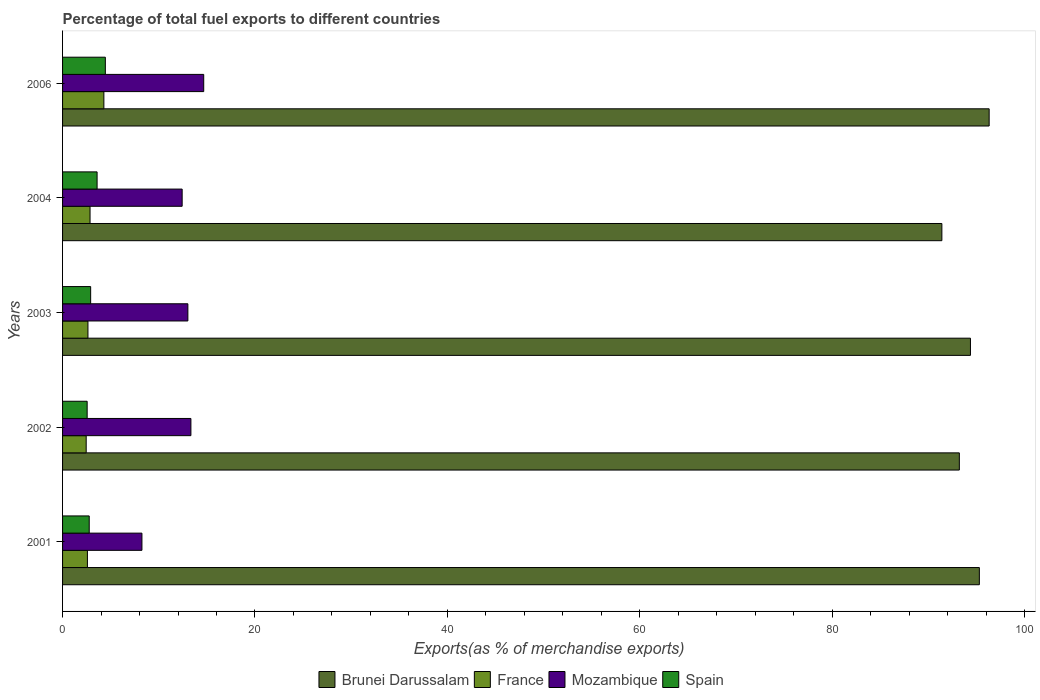How many different coloured bars are there?
Provide a succinct answer. 4. Are the number of bars per tick equal to the number of legend labels?
Give a very brief answer. Yes. Are the number of bars on each tick of the Y-axis equal?
Your answer should be compact. Yes. How many bars are there on the 4th tick from the top?
Your answer should be compact. 4. What is the label of the 1st group of bars from the top?
Offer a terse response. 2006. In how many cases, is the number of bars for a given year not equal to the number of legend labels?
Make the answer very short. 0. What is the percentage of exports to different countries in France in 2006?
Keep it short and to the point. 4.29. Across all years, what is the maximum percentage of exports to different countries in Brunei Darussalam?
Offer a terse response. 96.33. Across all years, what is the minimum percentage of exports to different countries in Brunei Darussalam?
Offer a terse response. 91.41. In which year was the percentage of exports to different countries in Spain maximum?
Your answer should be very brief. 2006. What is the total percentage of exports to different countries in Mozambique in the graph?
Make the answer very short. 61.73. What is the difference between the percentage of exports to different countries in Spain in 2002 and that in 2006?
Your answer should be compact. -1.89. What is the difference between the percentage of exports to different countries in France in 2004 and the percentage of exports to different countries in Mozambique in 2002?
Make the answer very short. -10.49. What is the average percentage of exports to different countries in France per year?
Provide a succinct answer. 2.97. In the year 2006, what is the difference between the percentage of exports to different countries in France and percentage of exports to different countries in Mozambique?
Your answer should be compact. -10.38. What is the ratio of the percentage of exports to different countries in Mozambique in 2001 to that in 2003?
Offer a very short reply. 0.63. Is the percentage of exports to different countries in Spain in 2002 less than that in 2004?
Keep it short and to the point. Yes. What is the difference between the highest and the second highest percentage of exports to different countries in Mozambique?
Your answer should be very brief. 1.33. What is the difference between the highest and the lowest percentage of exports to different countries in Spain?
Give a very brief answer. 1.89. In how many years, is the percentage of exports to different countries in Mozambique greater than the average percentage of exports to different countries in Mozambique taken over all years?
Provide a short and direct response. 4. Is the sum of the percentage of exports to different countries in France in 2001 and 2004 greater than the maximum percentage of exports to different countries in Mozambique across all years?
Your answer should be compact. No. What does the 2nd bar from the top in 2006 represents?
Your response must be concise. Mozambique. What does the 4th bar from the bottom in 2006 represents?
Make the answer very short. Spain. Are all the bars in the graph horizontal?
Make the answer very short. Yes. What is the difference between two consecutive major ticks on the X-axis?
Give a very brief answer. 20. Does the graph contain grids?
Provide a short and direct response. No. What is the title of the graph?
Provide a succinct answer. Percentage of total fuel exports to different countries. What is the label or title of the X-axis?
Your answer should be compact. Exports(as % of merchandise exports). What is the label or title of the Y-axis?
Provide a short and direct response. Years. What is the Exports(as % of merchandise exports) of Brunei Darussalam in 2001?
Keep it short and to the point. 95.31. What is the Exports(as % of merchandise exports) of France in 2001?
Offer a terse response. 2.58. What is the Exports(as % of merchandise exports) of Mozambique in 2001?
Provide a short and direct response. 8.25. What is the Exports(as % of merchandise exports) of Spain in 2001?
Keep it short and to the point. 2.77. What is the Exports(as % of merchandise exports) in Brunei Darussalam in 2002?
Your answer should be compact. 93.23. What is the Exports(as % of merchandise exports) in France in 2002?
Offer a very short reply. 2.46. What is the Exports(as % of merchandise exports) in Mozambique in 2002?
Your response must be concise. 13.34. What is the Exports(as % of merchandise exports) of Spain in 2002?
Offer a terse response. 2.56. What is the Exports(as % of merchandise exports) in Brunei Darussalam in 2003?
Offer a very short reply. 94.38. What is the Exports(as % of merchandise exports) of France in 2003?
Your answer should be compact. 2.64. What is the Exports(as % of merchandise exports) of Mozambique in 2003?
Your response must be concise. 13.03. What is the Exports(as % of merchandise exports) in Spain in 2003?
Give a very brief answer. 2.92. What is the Exports(as % of merchandise exports) of Brunei Darussalam in 2004?
Your answer should be compact. 91.41. What is the Exports(as % of merchandise exports) of France in 2004?
Keep it short and to the point. 2.86. What is the Exports(as % of merchandise exports) of Mozambique in 2004?
Your answer should be compact. 12.43. What is the Exports(as % of merchandise exports) of Spain in 2004?
Give a very brief answer. 3.59. What is the Exports(as % of merchandise exports) in Brunei Darussalam in 2006?
Offer a very short reply. 96.33. What is the Exports(as % of merchandise exports) in France in 2006?
Offer a terse response. 4.29. What is the Exports(as % of merchandise exports) of Mozambique in 2006?
Offer a terse response. 14.67. What is the Exports(as % of merchandise exports) of Spain in 2006?
Your answer should be very brief. 4.45. Across all years, what is the maximum Exports(as % of merchandise exports) of Brunei Darussalam?
Keep it short and to the point. 96.33. Across all years, what is the maximum Exports(as % of merchandise exports) in France?
Your answer should be compact. 4.29. Across all years, what is the maximum Exports(as % of merchandise exports) in Mozambique?
Ensure brevity in your answer.  14.67. Across all years, what is the maximum Exports(as % of merchandise exports) in Spain?
Your answer should be very brief. 4.45. Across all years, what is the minimum Exports(as % of merchandise exports) in Brunei Darussalam?
Offer a very short reply. 91.41. Across all years, what is the minimum Exports(as % of merchandise exports) in France?
Give a very brief answer. 2.46. Across all years, what is the minimum Exports(as % of merchandise exports) of Mozambique?
Offer a very short reply. 8.25. Across all years, what is the minimum Exports(as % of merchandise exports) in Spain?
Keep it short and to the point. 2.56. What is the total Exports(as % of merchandise exports) in Brunei Darussalam in the graph?
Keep it short and to the point. 470.65. What is the total Exports(as % of merchandise exports) in France in the graph?
Your response must be concise. 14.83. What is the total Exports(as % of merchandise exports) in Mozambique in the graph?
Ensure brevity in your answer.  61.73. What is the total Exports(as % of merchandise exports) of Spain in the graph?
Ensure brevity in your answer.  16.28. What is the difference between the Exports(as % of merchandise exports) of Brunei Darussalam in 2001 and that in 2002?
Give a very brief answer. 2.08. What is the difference between the Exports(as % of merchandise exports) in France in 2001 and that in 2002?
Provide a succinct answer. 0.13. What is the difference between the Exports(as % of merchandise exports) in Mozambique in 2001 and that in 2002?
Give a very brief answer. -5.09. What is the difference between the Exports(as % of merchandise exports) in Spain in 2001 and that in 2002?
Ensure brevity in your answer.  0.22. What is the difference between the Exports(as % of merchandise exports) in Brunei Darussalam in 2001 and that in 2003?
Provide a succinct answer. 0.92. What is the difference between the Exports(as % of merchandise exports) of France in 2001 and that in 2003?
Ensure brevity in your answer.  -0.05. What is the difference between the Exports(as % of merchandise exports) in Mozambique in 2001 and that in 2003?
Ensure brevity in your answer.  -4.78. What is the difference between the Exports(as % of merchandise exports) of Spain in 2001 and that in 2003?
Offer a terse response. -0.15. What is the difference between the Exports(as % of merchandise exports) of Brunei Darussalam in 2001 and that in 2004?
Give a very brief answer. 3.9. What is the difference between the Exports(as % of merchandise exports) of France in 2001 and that in 2004?
Provide a short and direct response. -0.27. What is the difference between the Exports(as % of merchandise exports) of Mozambique in 2001 and that in 2004?
Your answer should be very brief. -4.18. What is the difference between the Exports(as % of merchandise exports) of Spain in 2001 and that in 2004?
Your response must be concise. -0.82. What is the difference between the Exports(as % of merchandise exports) of Brunei Darussalam in 2001 and that in 2006?
Give a very brief answer. -1.02. What is the difference between the Exports(as % of merchandise exports) of France in 2001 and that in 2006?
Your response must be concise. -1.71. What is the difference between the Exports(as % of merchandise exports) in Mozambique in 2001 and that in 2006?
Provide a short and direct response. -6.42. What is the difference between the Exports(as % of merchandise exports) of Spain in 2001 and that in 2006?
Provide a short and direct response. -1.68. What is the difference between the Exports(as % of merchandise exports) in Brunei Darussalam in 2002 and that in 2003?
Provide a succinct answer. -1.16. What is the difference between the Exports(as % of merchandise exports) in France in 2002 and that in 2003?
Offer a terse response. -0.18. What is the difference between the Exports(as % of merchandise exports) of Mozambique in 2002 and that in 2003?
Provide a succinct answer. 0.32. What is the difference between the Exports(as % of merchandise exports) of Spain in 2002 and that in 2003?
Make the answer very short. -0.36. What is the difference between the Exports(as % of merchandise exports) of Brunei Darussalam in 2002 and that in 2004?
Your answer should be very brief. 1.82. What is the difference between the Exports(as % of merchandise exports) in France in 2002 and that in 2004?
Your answer should be very brief. -0.4. What is the difference between the Exports(as % of merchandise exports) in Mozambique in 2002 and that in 2004?
Ensure brevity in your answer.  0.91. What is the difference between the Exports(as % of merchandise exports) of Spain in 2002 and that in 2004?
Offer a terse response. -1.03. What is the difference between the Exports(as % of merchandise exports) of Brunei Darussalam in 2002 and that in 2006?
Your answer should be very brief. -3.1. What is the difference between the Exports(as % of merchandise exports) of France in 2002 and that in 2006?
Offer a very short reply. -1.84. What is the difference between the Exports(as % of merchandise exports) in Mozambique in 2002 and that in 2006?
Provide a short and direct response. -1.33. What is the difference between the Exports(as % of merchandise exports) of Spain in 2002 and that in 2006?
Offer a terse response. -1.89. What is the difference between the Exports(as % of merchandise exports) in Brunei Darussalam in 2003 and that in 2004?
Your answer should be very brief. 2.97. What is the difference between the Exports(as % of merchandise exports) in France in 2003 and that in 2004?
Keep it short and to the point. -0.22. What is the difference between the Exports(as % of merchandise exports) of Mozambique in 2003 and that in 2004?
Ensure brevity in your answer.  0.59. What is the difference between the Exports(as % of merchandise exports) of Spain in 2003 and that in 2004?
Provide a succinct answer. -0.67. What is the difference between the Exports(as % of merchandise exports) in Brunei Darussalam in 2003 and that in 2006?
Your response must be concise. -1.94. What is the difference between the Exports(as % of merchandise exports) of France in 2003 and that in 2006?
Provide a short and direct response. -1.66. What is the difference between the Exports(as % of merchandise exports) in Mozambique in 2003 and that in 2006?
Offer a very short reply. -1.65. What is the difference between the Exports(as % of merchandise exports) of Spain in 2003 and that in 2006?
Give a very brief answer. -1.53. What is the difference between the Exports(as % of merchandise exports) of Brunei Darussalam in 2004 and that in 2006?
Provide a short and direct response. -4.92. What is the difference between the Exports(as % of merchandise exports) of France in 2004 and that in 2006?
Your answer should be compact. -1.44. What is the difference between the Exports(as % of merchandise exports) in Mozambique in 2004 and that in 2006?
Provide a succinct answer. -2.24. What is the difference between the Exports(as % of merchandise exports) of Spain in 2004 and that in 2006?
Offer a very short reply. -0.86. What is the difference between the Exports(as % of merchandise exports) of Brunei Darussalam in 2001 and the Exports(as % of merchandise exports) of France in 2002?
Offer a terse response. 92.85. What is the difference between the Exports(as % of merchandise exports) in Brunei Darussalam in 2001 and the Exports(as % of merchandise exports) in Mozambique in 2002?
Offer a very short reply. 81.96. What is the difference between the Exports(as % of merchandise exports) in Brunei Darussalam in 2001 and the Exports(as % of merchandise exports) in Spain in 2002?
Offer a very short reply. 92.75. What is the difference between the Exports(as % of merchandise exports) of France in 2001 and the Exports(as % of merchandise exports) of Mozambique in 2002?
Provide a succinct answer. -10.76. What is the difference between the Exports(as % of merchandise exports) of France in 2001 and the Exports(as % of merchandise exports) of Spain in 2002?
Offer a very short reply. 0.03. What is the difference between the Exports(as % of merchandise exports) in Mozambique in 2001 and the Exports(as % of merchandise exports) in Spain in 2002?
Offer a very short reply. 5.69. What is the difference between the Exports(as % of merchandise exports) in Brunei Darussalam in 2001 and the Exports(as % of merchandise exports) in France in 2003?
Your answer should be very brief. 92.67. What is the difference between the Exports(as % of merchandise exports) of Brunei Darussalam in 2001 and the Exports(as % of merchandise exports) of Mozambique in 2003?
Your answer should be compact. 82.28. What is the difference between the Exports(as % of merchandise exports) of Brunei Darussalam in 2001 and the Exports(as % of merchandise exports) of Spain in 2003?
Provide a succinct answer. 92.39. What is the difference between the Exports(as % of merchandise exports) of France in 2001 and the Exports(as % of merchandise exports) of Mozambique in 2003?
Offer a very short reply. -10.44. What is the difference between the Exports(as % of merchandise exports) in France in 2001 and the Exports(as % of merchandise exports) in Spain in 2003?
Offer a terse response. -0.34. What is the difference between the Exports(as % of merchandise exports) of Mozambique in 2001 and the Exports(as % of merchandise exports) of Spain in 2003?
Offer a very short reply. 5.33. What is the difference between the Exports(as % of merchandise exports) of Brunei Darussalam in 2001 and the Exports(as % of merchandise exports) of France in 2004?
Keep it short and to the point. 92.45. What is the difference between the Exports(as % of merchandise exports) in Brunei Darussalam in 2001 and the Exports(as % of merchandise exports) in Mozambique in 2004?
Give a very brief answer. 82.87. What is the difference between the Exports(as % of merchandise exports) in Brunei Darussalam in 2001 and the Exports(as % of merchandise exports) in Spain in 2004?
Provide a succinct answer. 91.72. What is the difference between the Exports(as % of merchandise exports) of France in 2001 and the Exports(as % of merchandise exports) of Mozambique in 2004?
Your response must be concise. -9.85. What is the difference between the Exports(as % of merchandise exports) of France in 2001 and the Exports(as % of merchandise exports) of Spain in 2004?
Make the answer very short. -1.01. What is the difference between the Exports(as % of merchandise exports) in Mozambique in 2001 and the Exports(as % of merchandise exports) in Spain in 2004?
Give a very brief answer. 4.66. What is the difference between the Exports(as % of merchandise exports) of Brunei Darussalam in 2001 and the Exports(as % of merchandise exports) of France in 2006?
Your answer should be compact. 91.01. What is the difference between the Exports(as % of merchandise exports) of Brunei Darussalam in 2001 and the Exports(as % of merchandise exports) of Mozambique in 2006?
Your response must be concise. 80.63. What is the difference between the Exports(as % of merchandise exports) in Brunei Darussalam in 2001 and the Exports(as % of merchandise exports) in Spain in 2006?
Your answer should be compact. 90.86. What is the difference between the Exports(as % of merchandise exports) in France in 2001 and the Exports(as % of merchandise exports) in Mozambique in 2006?
Provide a short and direct response. -12.09. What is the difference between the Exports(as % of merchandise exports) in France in 2001 and the Exports(as % of merchandise exports) in Spain in 2006?
Your response must be concise. -1.86. What is the difference between the Exports(as % of merchandise exports) of Mozambique in 2001 and the Exports(as % of merchandise exports) of Spain in 2006?
Make the answer very short. 3.8. What is the difference between the Exports(as % of merchandise exports) in Brunei Darussalam in 2002 and the Exports(as % of merchandise exports) in France in 2003?
Your answer should be very brief. 90.59. What is the difference between the Exports(as % of merchandise exports) of Brunei Darussalam in 2002 and the Exports(as % of merchandise exports) of Mozambique in 2003?
Your answer should be very brief. 80.2. What is the difference between the Exports(as % of merchandise exports) in Brunei Darussalam in 2002 and the Exports(as % of merchandise exports) in Spain in 2003?
Make the answer very short. 90.31. What is the difference between the Exports(as % of merchandise exports) of France in 2002 and the Exports(as % of merchandise exports) of Mozambique in 2003?
Your response must be concise. -10.57. What is the difference between the Exports(as % of merchandise exports) of France in 2002 and the Exports(as % of merchandise exports) of Spain in 2003?
Your answer should be compact. -0.46. What is the difference between the Exports(as % of merchandise exports) in Mozambique in 2002 and the Exports(as % of merchandise exports) in Spain in 2003?
Your answer should be compact. 10.42. What is the difference between the Exports(as % of merchandise exports) in Brunei Darussalam in 2002 and the Exports(as % of merchandise exports) in France in 2004?
Make the answer very short. 90.37. What is the difference between the Exports(as % of merchandise exports) in Brunei Darussalam in 2002 and the Exports(as % of merchandise exports) in Mozambique in 2004?
Ensure brevity in your answer.  80.79. What is the difference between the Exports(as % of merchandise exports) in Brunei Darussalam in 2002 and the Exports(as % of merchandise exports) in Spain in 2004?
Your answer should be very brief. 89.64. What is the difference between the Exports(as % of merchandise exports) in France in 2002 and the Exports(as % of merchandise exports) in Mozambique in 2004?
Offer a very short reply. -9.98. What is the difference between the Exports(as % of merchandise exports) of France in 2002 and the Exports(as % of merchandise exports) of Spain in 2004?
Offer a very short reply. -1.13. What is the difference between the Exports(as % of merchandise exports) in Mozambique in 2002 and the Exports(as % of merchandise exports) in Spain in 2004?
Make the answer very short. 9.75. What is the difference between the Exports(as % of merchandise exports) of Brunei Darussalam in 2002 and the Exports(as % of merchandise exports) of France in 2006?
Keep it short and to the point. 88.93. What is the difference between the Exports(as % of merchandise exports) in Brunei Darussalam in 2002 and the Exports(as % of merchandise exports) in Mozambique in 2006?
Provide a short and direct response. 78.55. What is the difference between the Exports(as % of merchandise exports) of Brunei Darussalam in 2002 and the Exports(as % of merchandise exports) of Spain in 2006?
Provide a succinct answer. 88.78. What is the difference between the Exports(as % of merchandise exports) in France in 2002 and the Exports(as % of merchandise exports) in Mozambique in 2006?
Ensure brevity in your answer.  -12.22. What is the difference between the Exports(as % of merchandise exports) of France in 2002 and the Exports(as % of merchandise exports) of Spain in 2006?
Give a very brief answer. -1.99. What is the difference between the Exports(as % of merchandise exports) in Mozambique in 2002 and the Exports(as % of merchandise exports) in Spain in 2006?
Offer a very short reply. 8.9. What is the difference between the Exports(as % of merchandise exports) in Brunei Darussalam in 2003 and the Exports(as % of merchandise exports) in France in 2004?
Offer a terse response. 91.52. What is the difference between the Exports(as % of merchandise exports) in Brunei Darussalam in 2003 and the Exports(as % of merchandise exports) in Mozambique in 2004?
Make the answer very short. 81.95. What is the difference between the Exports(as % of merchandise exports) in Brunei Darussalam in 2003 and the Exports(as % of merchandise exports) in Spain in 2004?
Keep it short and to the point. 90.79. What is the difference between the Exports(as % of merchandise exports) of France in 2003 and the Exports(as % of merchandise exports) of Mozambique in 2004?
Provide a succinct answer. -9.79. What is the difference between the Exports(as % of merchandise exports) in France in 2003 and the Exports(as % of merchandise exports) in Spain in 2004?
Give a very brief answer. -0.95. What is the difference between the Exports(as % of merchandise exports) in Mozambique in 2003 and the Exports(as % of merchandise exports) in Spain in 2004?
Provide a short and direct response. 9.44. What is the difference between the Exports(as % of merchandise exports) of Brunei Darussalam in 2003 and the Exports(as % of merchandise exports) of France in 2006?
Provide a short and direct response. 90.09. What is the difference between the Exports(as % of merchandise exports) in Brunei Darussalam in 2003 and the Exports(as % of merchandise exports) in Mozambique in 2006?
Your answer should be compact. 79.71. What is the difference between the Exports(as % of merchandise exports) in Brunei Darussalam in 2003 and the Exports(as % of merchandise exports) in Spain in 2006?
Your answer should be compact. 89.93. What is the difference between the Exports(as % of merchandise exports) in France in 2003 and the Exports(as % of merchandise exports) in Mozambique in 2006?
Offer a very short reply. -12.04. What is the difference between the Exports(as % of merchandise exports) in France in 2003 and the Exports(as % of merchandise exports) in Spain in 2006?
Offer a terse response. -1.81. What is the difference between the Exports(as % of merchandise exports) in Mozambique in 2003 and the Exports(as % of merchandise exports) in Spain in 2006?
Your answer should be very brief. 8.58. What is the difference between the Exports(as % of merchandise exports) in Brunei Darussalam in 2004 and the Exports(as % of merchandise exports) in France in 2006?
Offer a terse response. 87.12. What is the difference between the Exports(as % of merchandise exports) of Brunei Darussalam in 2004 and the Exports(as % of merchandise exports) of Mozambique in 2006?
Your answer should be compact. 76.74. What is the difference between the Exports(as % of merchandise exports) of Brunei Darussalam in 2004 and the Exports(as % of merchandise exports) of Spain in 2006?
Keep it short and to the point. 86.96. What is the difference between the Exports(as % of merchandise exports) of France in 2004 and the Exports(as % of merchandise exports) of Mozambique in 2006?
Provide a succinct answer. -11.82. What is the difference between the Exports(as % of merchandise exports) of France in 2004 and the Exports(as % of merchandise exports) of Spain in 2006?
Your answer should be very brief. -1.59. What is the difference between the Exports(as % of merchandise exports) in Mozambique in 2004 and the Exports(as % of merchandise exports) in Spain in 2006?
Your response must be concise. 7.99. What is the average Exports(as % of merchandise exports) of Brunei Darussalam per year?
Provide a succinct answer. 94.13. What is the average Exports(as % of merchandise exports) in France per year?
Ensure brevity in your answer.  2.97. What is the average Exports(as % of merchandise exports) in Mozambique per year?
Offer a terse response. 12.35. What is the average Exports(as % of merchandise exports) in Spain per year?
Provide a succinct answer. 3.26. In the year 2001, what is the difference between the Exports(as % of merchandise exports) in Brunei Darussalam and Exports(as % of merchandise exports) in France?
Provide a succinct answer. 92.72. In the year 2001, what is the difference between the Exports(as % of merchandise exports) of Brunei Darussalam and Exports(as % of merchandise exports) of Mozambique?
Provide a short and direct response. 87.06. In the year 2001, what is the difference between the Exports(as % of merchandise exports) in Brunei Darussalam and Exports(as % of merchandise exports) in Spain?
Make the answer very short. 92.53. In the year 2001, what is the difference between the Exports(as % of merchandise exports) in France and Exports(as % of merchandise exports) in Mozambique?
Keep it short and to the point. -5.67. In the year 2001, what is the difference between the Exports(as % of merchandise exports) in France and Exports(as % of merchandise exports) in Spain?
Your answer should be compact. -0.19. In the year 2001, what is the difference between the Exports(as % of merchandise exports) in Mozambique and Exports(as % of merchandise exports) in Spain?
Offer a very short reply. 5.48. In the year 2002, what is the difference between the Exports(as % of merchandise exports) of Brunei Darussalam and Exports(as % of merchandise exports) of France?
Make the answer very short. 90.77. In the year 2002, what is the difference between the Exports(as % of merchandise exports) in Brunei Darussalam and Exports(as % of merchandise exports) in Mozambique?
Provide a succinct answer. 79.88. In the year 2002, what is the difference between the Exports(as % of merchandise exports) of Brunei Darussalam and Exports(as % of merchandise exports) of Spain?
Keep it short and to the point. 90.67. In the year 2002, what is the difference between the Exports(as % of merchandise exports) in France and Exports(as % of merchandise exports) in Mozambique?
Your answer should be very brief. -10.89. In the year 2002, what is the difference between the Exports(as % of merchandise exports) of France and Exports(as % of merchandise exports) of Spain?
Your answer should be very brief. -0.1. In the year 2002, what is the difference between the Exports(as % of merchandise exports) of Mozambique and Exports(as % of merchandise exports) of Spain?
Offer a very short reply. 10.79. In the year 2003, what is the difference between the Exports(as % of merchandise exports) of Brunei Darussalam and Exports(as % of merchandise exports) of France?
Make the answer very short. 91.74. In the year 2003, what is the difference between the Exports(as % of merchandise exports) of Brunei Darussalam and Exports(as % of merchandise exports) of Mozambique?
Keep it short and to the point. 81.35. In the year 2003, what is the difference between the Exports(as % of merchandise exports) of Brunei Darussalam and Exports(as % of merchandise exports) of Spain?
Your answer should be compact. 91.46. In the year 2003, what is the difference between the Exports(as % of merchandise exports) of France and Exports(as % of merchandise exports) of Mozambique?
Your answer should be very brief. -10.39. In the year 2003, what is the difference between the Exports(as % of merchandise exports) of France and Exports(as % of merchandise exports) of Spain?
Ensure brevity in your answer.  -0.28. In the year 2003, what is the difference between the Exports(as % of merchandise exports) of Mozambique and Exports(as % of merchandise exports) of Spain?
Provide a succinct answer. 10.11. In the year 2004, what is the difference between the Exports(as % of merchandise exports) in Brunei Darussalam and Exports(as % of merchandise exports) in France?
Keep it short and to the point. 88.55. In the year 2004, what is the difference between the Exports(as % of merchandise exports) in Brunei Darussalam and Exports(as % of merchandise exports) in Mozambique?
Provide a succinct answer. 78.98. In the year 2004, what is the difference between the Exports(as % of merchandise exports) of Brunei Darussalam and Exports(as % of merchandise exports) of Spain?
Ensure brevity in your answer.  87.82. In the year 2004, what is the difference between the Exports(as % of merchandise exports) in France and Exports(as % of merchandise exports) in Mozambique?
Give a very brief answer. -9.58. In the year 2004, what is the difference between the Exports(as % of merchandise exports) in France and Exports(as % of merchandise exports) in Spain?
Your answer should be compact. -0.73. In the year 2004, what is the difference between the Exports(as % of merchandise exports) in Mozambique and Exports(as % of merchandise exports) in Spain?
Make the answer very short. 8.84. In the year 2006, what is the difference between the Exports(as % of merchandise exports) in Brunei Darussalam and Exports(as % of merchandise exports) in France?
Ensure brevity in your answer.  92.03. In the year 2006, what is the difference between the Exports(as % of merchandise exports) of Brunei Darussalam and Exports(as % of merchandise exports) of Mozambique?
Your answer should be very brief. 81.65. In the year 2006, what is the difference between the Exports(as % of merchandise exports) in Brunei Darussalam and Exports(as % of merchandise exports) in Spain?
Make the answer very short. 91.88. In the year 2006, what is the difference between the Exports(as % of merchandise exports) in France and Exports(as % of merchandise exports) in Mozambique?
Offer a terse response. -10.38. In the year 2006, what is the difference between the Exports(as % of merchandise exports) of France and Exports(as % of merchandise exports) of Spain?
Provide a succinct answer. -0.15. In the year 2006, what is the difference between the Exports(as % of merchandise exports) of Mozambique and Exports(as % of merchandise exports) of Spain?
Provide a short and direct response. 10.23. What is the ratio of the Exports(as % of merchandise exports) of Brunei Darussalam in 2001 to that in 2002?
Make the answer very short. 1.02. What is the ratio of the Exports(as % of merchandise exports) in France in 2001 to that in 2002?
Ensure brevity in your answer.  1.05. What is the ratio of the Exports(as % of merchandise exports) in Mozambique in 2001 to that in 2002?
Keep it short and to the point. 0.62. What is the ratio of the Exports(as % of merchandise exports) in Spain in 2001 to that in 2002?
Your answer should be very brief. 1.08. What is the ratio of the Exports(as % of merchandise exports) in Brunei Darussalam in 2001 to that in 2003?
Your answer should be compact. 1.01. What is the ratio of the Exports(as % of merchandise exports) of France in 2001 to that in 2003?
Provide a succinct answer. 0.98. What is the ratio of the Exports(as % of merchandise exports) in Mozambique in 2001 to that in 2003?
Make the answer very short. 0.63. What is the ratio of the Exports(as % of merchandise exports) in Spain in 2001 to that in 2003?
Provide a short and direct response. 0.95. What is the ratio of the Exports(as % of merchandise exports) in Brunei Darussalam in 2001 to that in 2004?
Offer a very short reply. 1.04. What is the ratio of the Exports(as % of merchandise exports) in France in 2001 to that in 2004?
Provide a succinct answer. 0.9. What is the ratio of the Exports(as % of merchandise exports) in Mozambique in 2001 to that in 2004?
Offer a very short reply. 0.66. What is the ratio of the Exports(as % of merchandise exports) of Spain in 2001 to that in 2004?
Keep it short and to the point. 0.77. What is the ratio of the Exports(as % of merchandise exports) of Brunei Darussalam in 2001 to that in 2006?
Provide a succinct answer. 0.99. What is the ratio of the Exports(as % of merchandise exports) of France in 2001 to that in 2006?
Your response must be concise. 0.6. What is the ratio of the Exports(as % of merchandise exports) in Mozambique in 2001 to that in 2006?
Keep it short and to the point. 0.56. What is the ratio of the Exports(as % of merchandise exports) of Spain in 2001 to that in 2006?
Keep it short and to the point. 0.62. What is the ratio of the Exports(as % of merchandise exports) in France in 2002 to that in 2003?
Keep it short and to the point. 0.93. What is the ratio of the Exports(as % of merchandise exports) of Mozambique in 2002 to that in 2003?
Offer a terse response. 1.02. What is the ratio of the Exports(as % of merchandise exports) in Spain in 2002 to that in 2003?
Offer a terse response. 0.88. What is the ratio of the Exports(as % of merchandise exports) in Brunei Darussalam in 2002 to that in 2004?
Provide a succinct answer. 1.02. What is the ratio of the Exports(as % of merchandise exports) in France in 2002 to that in 2004?
Offer a very short reply. 0.86. What is the ratio of the Exports(as % of merchandise exports) in Mozambique in 2002 to that in 2004?
Offer a very short reply. 1.07. What is the ratio of the Exports(as % of merchandise exports) of Spain in 2002 to that in 2004?
Ensure brevity in your answer.  0.71. What is the ratio of the Exports(as % of merchandise exports) in Brunei Darussalam in 2002 to that in 2006?
Keep it short and to the point. 0.97. What is the ratio of the Exports(as % of merchandise exports) of France in 2002 to that in 2006?
Provide a succinct answer. 0.57. What is the ratio of the Exports(as % of merchandise exports) of Mozambique in 2002 to that in 2006?
Offer a terse response. 0.91. What is the ratio of the Exports(as % of merchandise exports) of Spain in 2002 to that in 2006?
Ensure brevity in your answer.  0.57. What is the ratio of the Exports(as % of merchandise exports) in Brunei Darussalam in 2003 to that in 2004?
Offer a very short reply. 1.03. What is the ratio of the Exports(as % of merchandise exports) of France in 2003 to that in 2004?
Your answer should be very brief. 0.92. What is the ratio of the Exports(as % of merchandise exports) in Mozambique in 2003 to that in 2004?
Offer a terse response. 1.05. What is the ratio of the Exports(as % of merchandise exports) of Spain in 2003 to that in 2004?
Your answer should be very brief. 0.81. What is the ratio of the Exports(as % of merchandise exports) in Brunei Darussalam in 2003 to that in 2006?
Make the answer very short. 0.98. What is the ratio of the Exports(as % of merchandise exports) of France in 2003 to that in 2006?
Offer a terse response. 0.61. What is the ratio of the Exports(as % of merchandise exports) of Mozambique in 2003 to that in 2006?
Provide a short and direct response. 0.89. What is the ratio of the Exports(as % of merchandise exports) of Spain in 2003 to that in 2006?
Ensure brevity in your answer.  0.66. What is the ratio of the Exports(as % of merchandise exports) in Brunei Darussalam in 2004 to that in 2006?
Your response must be concise. 0.95. What is the ratio of the Exports(as % of merchandise exports) in France in 2004 to that in 2006?
Offer a terse response. 0.67. What is the ratio of the Exports(as % of merchandise exports) in Mozambique in 2004 to that in 2006?
Your answer should be compact. 0.85. What is the ratio of the Exports(as % of merchandise exports) of Spain in 2004 to that in 2006?
Your answer should be very brief. 0.81. What is the difference between the highest and the second highest Exports(as % of merchandise exports) in Brunei Darussalam?
Keep it short and to the point. 1.02. What is the difference between the highest and the second highest Exports(as % of merchandise exports) in France?
Offer a terse response. 1.44. What is the difference between the highest and the second highest Exports(as % of merchandise exports) of Mozambique?
Keep it short and to the point. 1.33. What is the difference between the highest and the second highest Exports(as % of merchandise exports) in Spain?
Provide a succinct answer. 0.86. What is the difference between the highest and the lowest Exports(as % of merchandise exports) of Brunei Darussalam?
Ensure brevity in your answer.  4.92. What is the difference between the highest and the lowest Exports(as % of merchandise exports) of France?
Provide a short and direct response. 1.84. What is the difference between the highest and the lowest Exports(as % of merchandise exports) in Mozambique?
Give a very brief answer. 6.42. What is the difference between the highest and the lowest Exports(as % of merchandise exports) in Spain?
Provide a succinct answer. 1.89. 